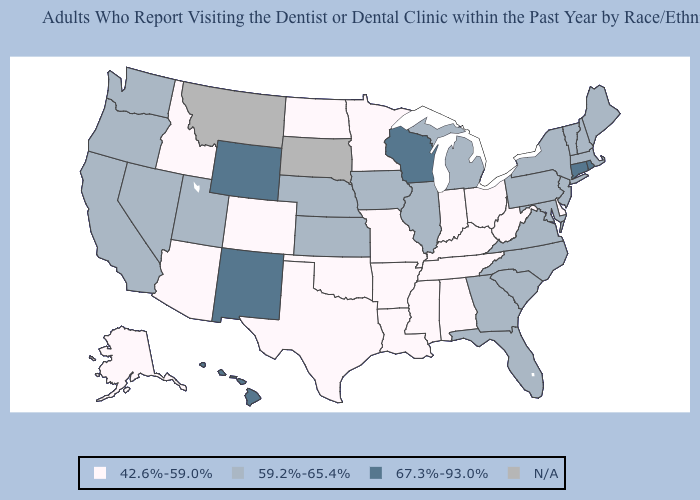Name the states that have a value in the range N/A?
Write a very short answer. Montana, South Dakota. Which states hav the highest value in the West?
Concise answer only. Hawaii, New Mexico, Wyoming. What is the value of New Hampshire?
Answer briefly. 59.2%-65.4%. Does New Mexico have the highest value in the USA?
Quick response, please. Yes. Does the map have missing data?
Quick response, please. Yes. What is the lowest value in the USA?
Short answer required. 42.6%-59.0%. Which states have the lowest value in the Northeast?
Concise answer only. Maine, Massachusetts, New Hampshire, New Jersey, New York, Pennsylvania, Vermont. Which states hav the highest value in the West?
Give a very brief answer. Hawaii, New Mexico, Wyoming. Among the states that border West Virginia , which have the highest value?
Quick response, please. Maryland, Pennsylvania, Virginia. What is the lowest value in states that border Indiana?
Short answer required. 42.6%-59.0%. What is the highest value in the USA?
Concise answer only. 67.3%-93.0%. What is the value of Montana?
Keep it brief. N/A. Name the states that have a value in the range 59.2%-65.4%?
Give a very brief answer. California, Florida, Georgia, Illinois, Iowa, Kansas, Maine, Maryland, Massachusetts, Michigan, Nebraska, Nevada, New Hampshire, New Jersey, New York, North Carolina, Oregon, Pennsylvania, South Carolina, Utah, Vermont, Virginia, Washington. 